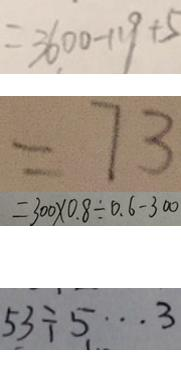<formula> <loc_0><loc_0><loc_500><loc_500>= 3 6 0 0 - 1 1 9 + 5 
 = 7 3 
 = 3 0 0 \times 0 . 8 \div 0 . 6 - 3 0 0 
 5 3 \div 5 \cdots 3</formula> 